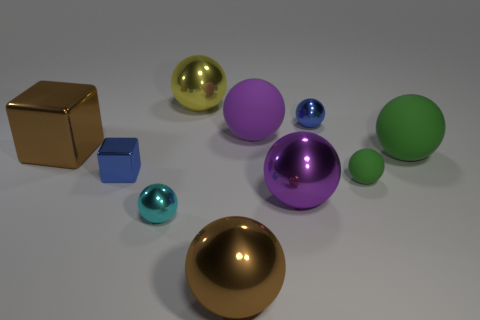Subtract all big green matte balls. How many balls are left? 7 Subtract all purple balls. How many balls are left? 6 Subtract all purple spheres. Subtract all purple cylinders. How many spheres are left? 6 Subtract all blocks. How many objects are left? 8 Add 7 large metallic balls. How many large metallic balls exist? 10 Subtract 0 yellow blocks. How many objects are left? 10 Subtract all yellow balls. Subtract all purple objects. How many objects are left? 7 Add 1 cyan metal spheres. How many cyan metal spheres are left? 2 